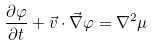<formula> <loc_0><loc_0><loc_500><loc_500>\frac { \partial \varphi } { \partial t } + \vec { v } \cdot \vec { \nabla } \varphi = \nabla ^ { 2 } \mu</formula> 